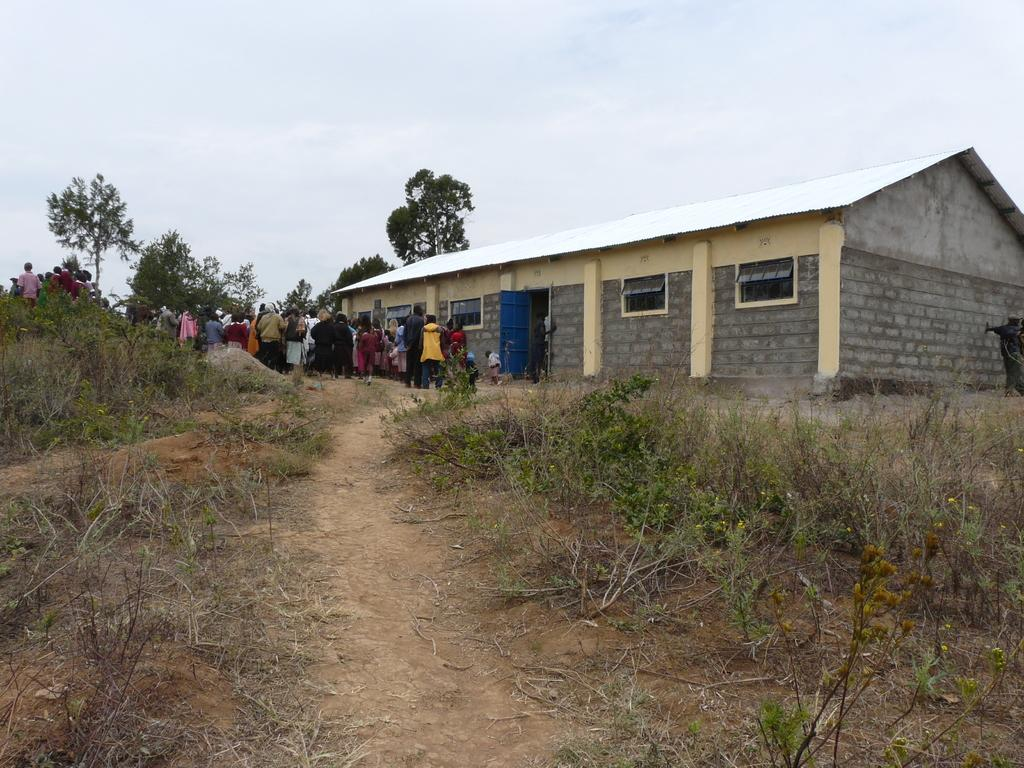What type of vegetation is present in the image? There is dry grass in the image. What type of structure can be seen in the image? There is a house in the image. Who or what is present in the image besides the house and dry grass? There are people and trees in the image. What is visible at the top of the image? The sky is visible at the top of the image. What type of health issues are the people in the image experiencing? There is no information about the health of the people in the image, so we cannot determine if they are experiencing any health issues. What type of plants are the people in the image holding? There are no plants visible in the image, and the people are not holding any plants. 